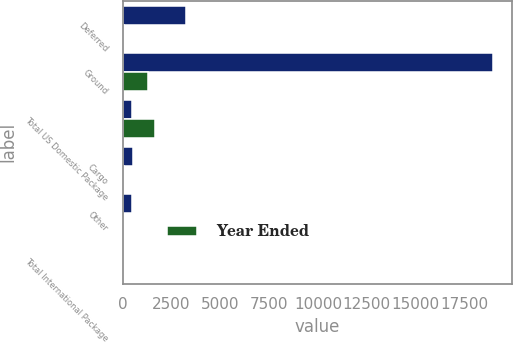<chart> <loc_0><loc_0><loc_500><loc_500><stacked_bar_chart><ecel><fcel>Deferred<fcel>Ground<fcel>Total US Domestic Package<fcel>Cargo<fcel>Other<fcel>Total International Package<nl><fcel>nan<fcel>3258<fcel>18971<fcel>460<fcel>533<fcel>460<fcel>19.13<nl><fcel>Year Ended<fcel>65<fcel>1288<fcel>1650<fcel>61<fcel>26<fcel>0.73<nl></chart> 